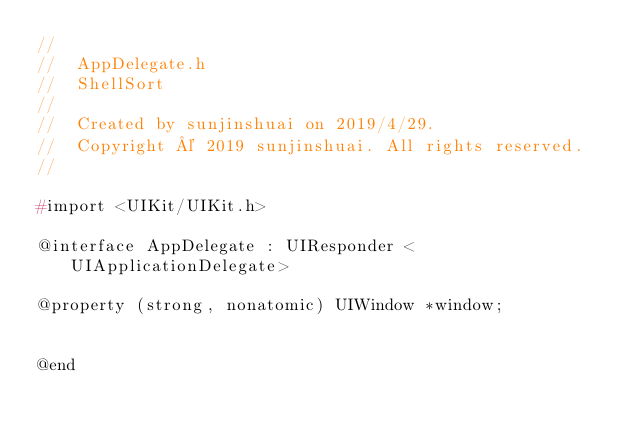<code> <loc_0><loc_0><loc_500><loc_500><_C_>//
//  AppDelegate.h
//  ShellSort
//
//  Created by sunjinshuai on 2019/4/29.
//  Copyright © 2019 sunjinshuai. All rights reserved.
//

#import <UIKit/UIKit.h>

@interface AppDelegate : UIResponder <UIApplicationDelegate>

@property (strong, nonatomic) UIWindow *window;


@end

</code> 